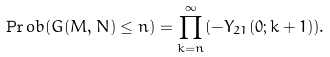<formula> <loc_0><loc_0><loc_500><loc_500>\Pr o b ( G ( M , N ) \leq n ) = \prod _ { k = n } ^ { \infty } ( - Y _ { 2 1 } ( 0 ; k + 1 ) ) .</formula> 